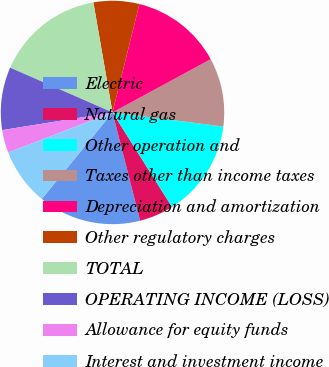Convert chart. <chart><loc_0><loc_0><loc_500><loc_500><pie_chart><fcel>Electric<fcel>Natural gas<fcel>Other operation and<fcel>Taxes other than income taxes<fcel>Depreciation and amortization<fcel>Other regulatory charges<fcel>TOTAL<fcel>OPERATING INCOME (LOSS)<fcel>Allowance for equity funds<fcel>Interest and investment income<nl><fcel>14.88%<fcel>4.96%<fcel>14.05%<fcel>9.92%<fcel>13.22%<fcel>6.61%<fcel>15.7%<fcel>9.09%<fcel>3.31%<fcel>8.26%<nl></chart> 